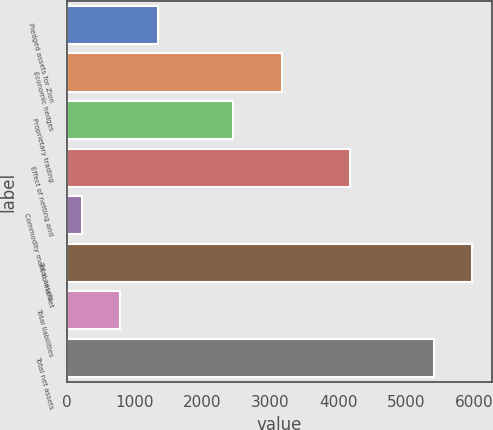Convert chart. <chart><loc_0><loc_0><loc_500><loc_500><bar_chart><fcel>Pledged assets for Zion<fcel>Economic hedges<fcel>Proprietary trading<fcel>Effect of netting and<fcel>Commodity mark-to-market<fcel>Total assets<fcel>Total liabilities<fcel>Total net assets<nl><fcel>1338<fcel>3173<fcel>2448<fcel>4175<fcel>228<fcel>5970<fcel>783<fcel>5415<nl></chart> 